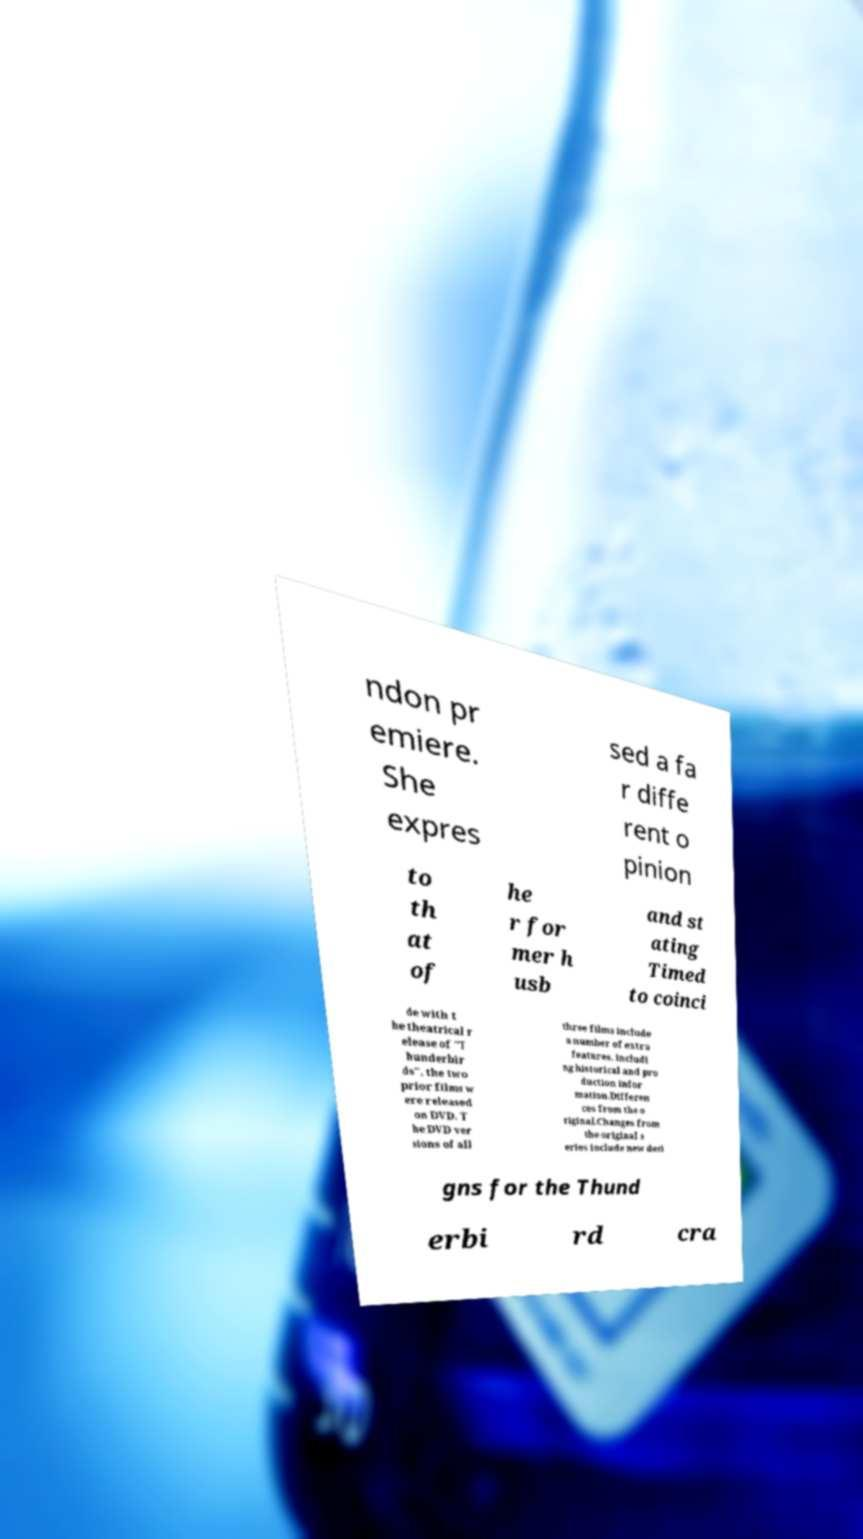I need the written content from this picture converted into text. Can you do that? ndon pr emiere. She expres sed a fa r diffe rent o pinion to th at of he r for mer h usb and st ating Timed to coinci de with t he theatrical r elease of "T hunderbir ds", the two prior films w ere released on DVD. T he DVD ver sions of all three films include a number of extra features, includi ng historical and pro duction infor mation.Differen ces from the o riginal.Changes from the original s eries include new desi gns for the Thund erbi rd cra 